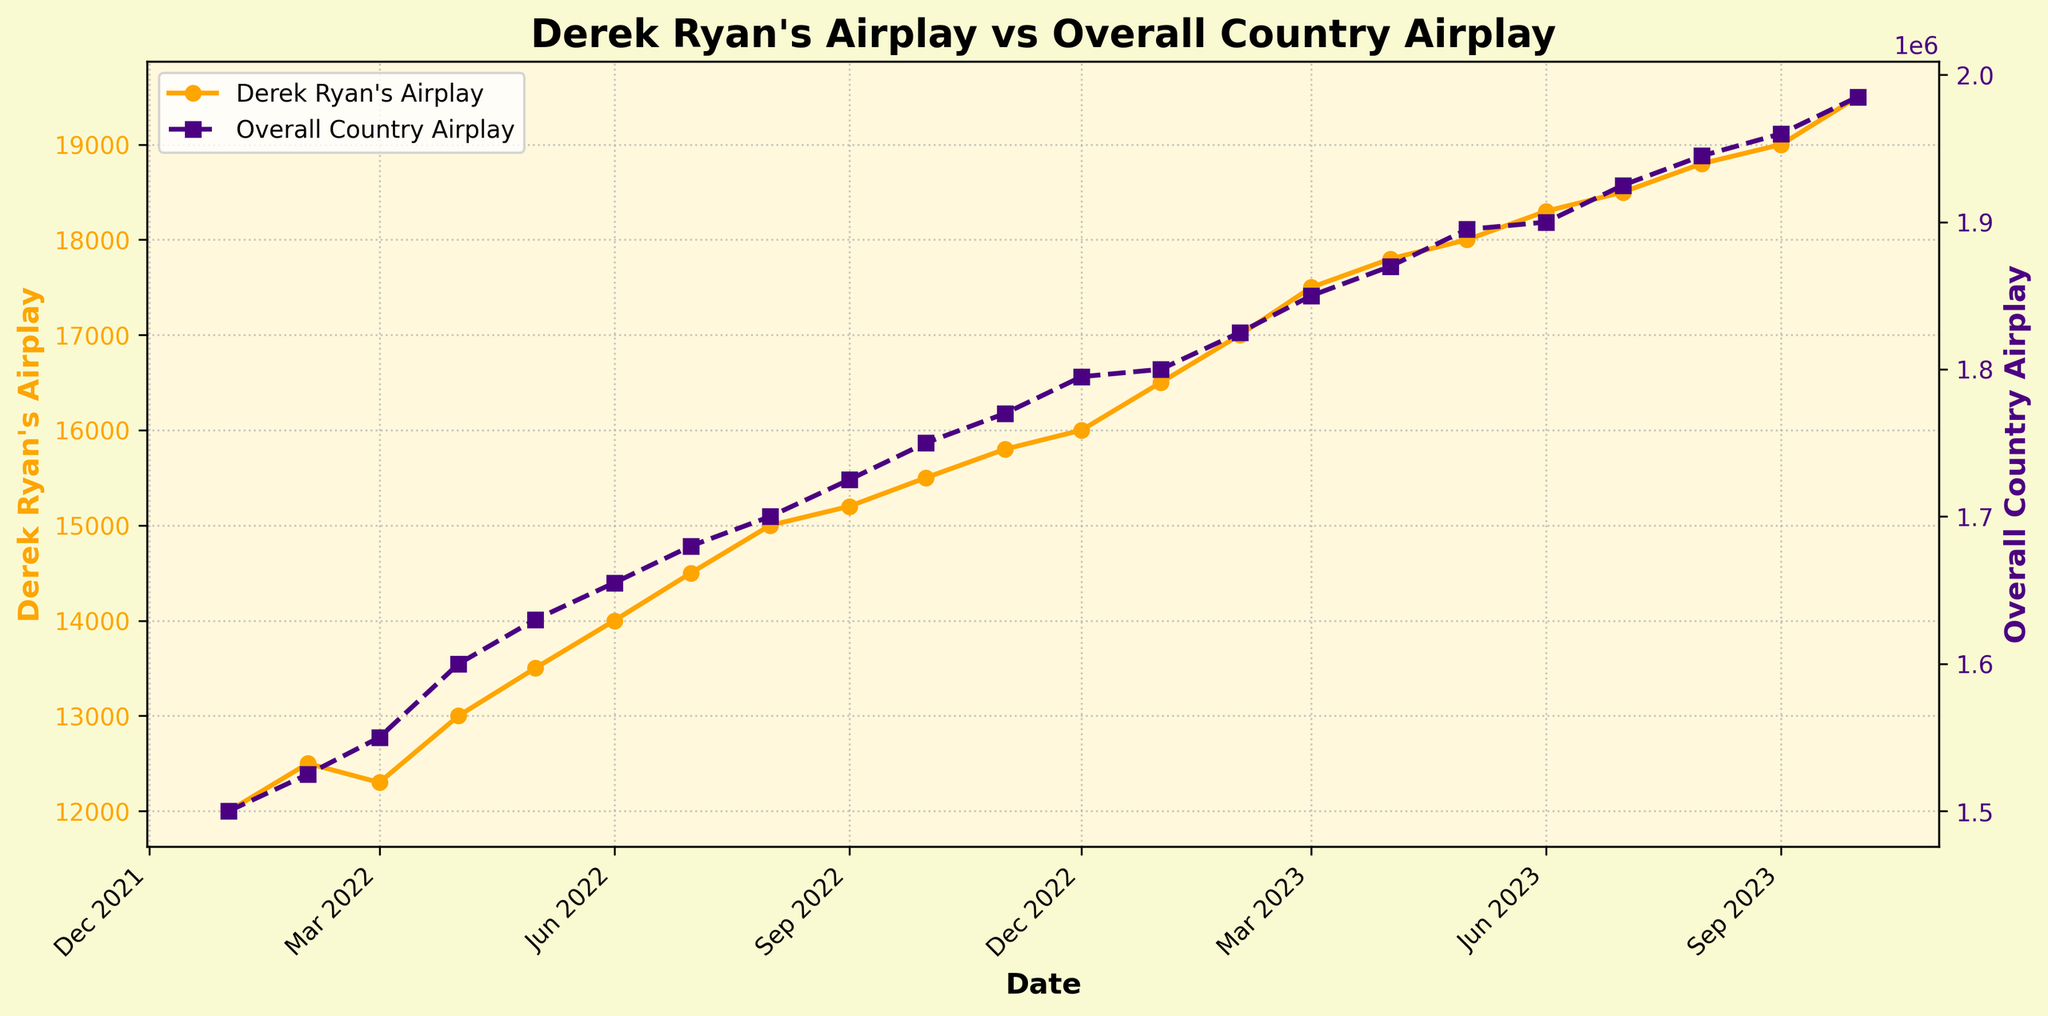What's the title of the plot? The title of the plot is displayed at the top of the figure, summarizing the data being represented.
Answer: Derek Ryan's Airplay vs Overall Country Airplay How many data points are plotted for each variable? Each data point represents a month, and the x-axis spans from January 2022 to October 2023. Counting each monthly mark, there are 22 data points plotted for each variable (Derek Ryan's Airplay and Overall Country Airplay).
Answer: 22 What is the airplay count for Derek Ryan in March 2023? To find this, locate the date March 2023 along the x-axis and then find the corresponding value on the left y-axis labeled "Derek Ryan's Airplay."
Answer: 17,500 How does the airplay of Derek Ryan in January 2023 compare to October 2023? Locate the values on the left y-axis for January 2023 and October 2023. Derek Ryan's Airplay is 16,500 in January 2023 and 19,500 in October 2023, showing an increase.
Answer: Increased by 3,000 What's the average airplay for Derek Ryan's singles over the entire period? Calculate the average by summing all the airplay values for Derek Ryan from January 2022 to October 2023 and dividing by the number of months (22). The sum is (12000 + 12500 + 12300 + ... + 19500) = 359,300. Divide by 22 to get the average: 359,300 / 22 = 16,331.82.
Answer: 16,331.82 When did Derek Ryan's airplay first exceed 18,000? To determine this, check the dates on the x-axis and corresponding airplay values on the left y-axis. Derek Ryan's airplay first exceeds 18,000 in June 2023.
Answer: June 2023 Which month had the highest overall country airplay, and what was it? Look at the right y-axis for overall country airplay and find the highest value, then trace it back to the corresponding month on the x-axis. October 2023 has the highest value of 1,985,000.
Answer: October 2023, 1,985,000 What's the difference in airplay for Derek Ryan between May 2023 and October 2023? Subtract Derek Ryan's airplay in May 2023 from his airplay in October 2023. October 2023 is 19,500 and May 2023 is 18,000, so the difference is 19,500 - 18,000 = 1,500.
Answer: 1,500 Did the overall country airplay ever decrease from one month to the next? Check the trend in the data points for overall country airplay along the right y-axis. Each data point from January 2022 to October 2023 shows an increase, therefore it never decreases.
Answer: No 